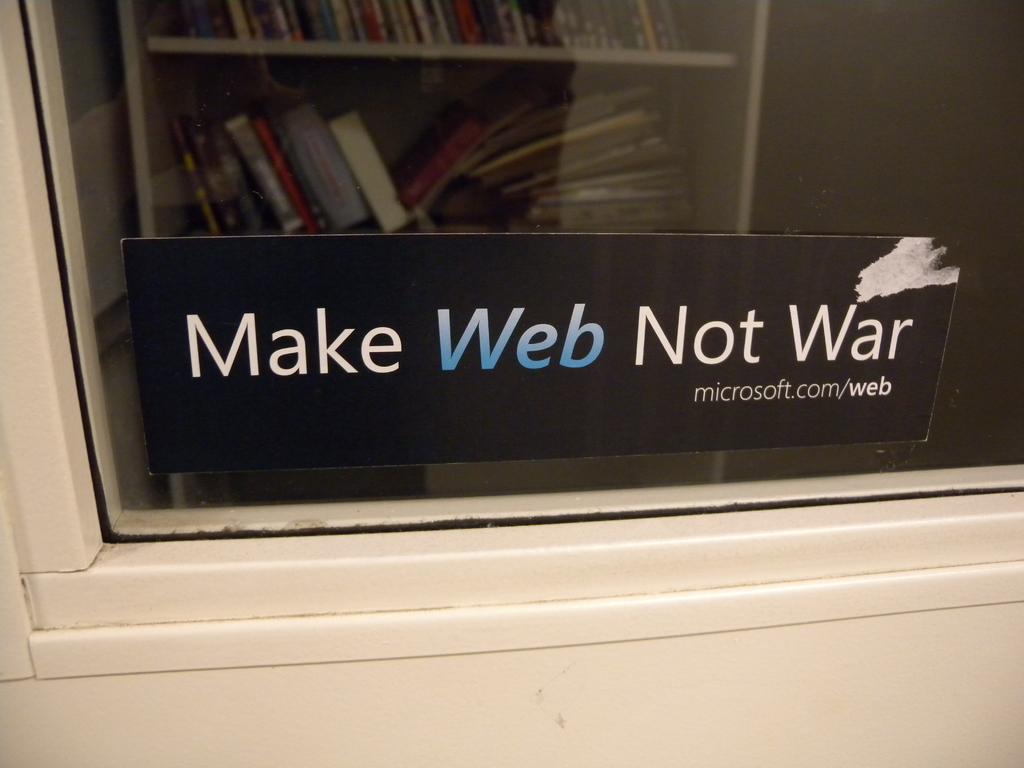What website is on the sticker?
Ensure brevity in your answer.  Microsoft.com/web. 